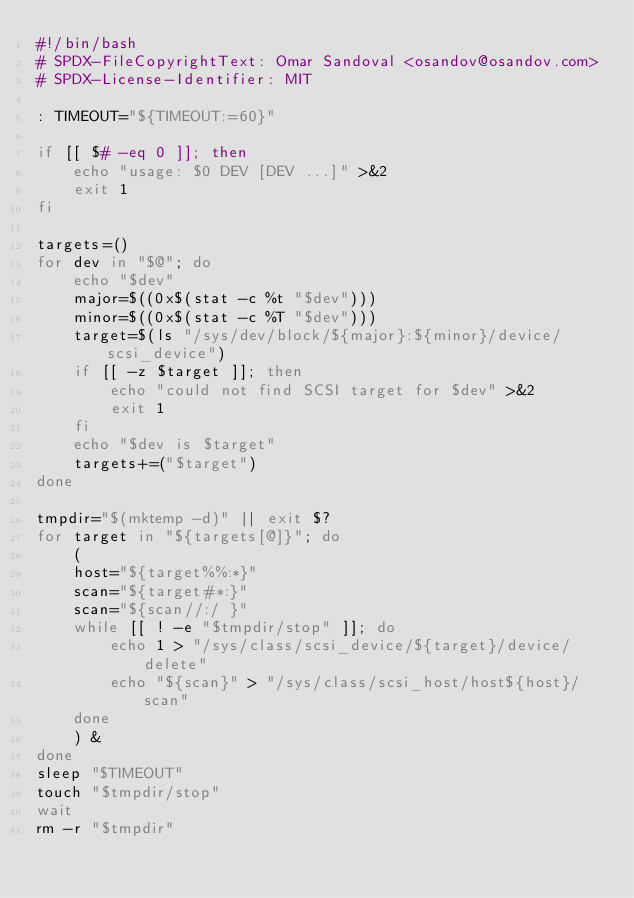Convert code to text. <code><loc_0><loc_0><loc_500><loc_500><_Bash_>#!/bin/bash
# SPDX-FileCopyrightText: Omar Sandoval <osandov@osandov.com>
# SPDX-License-Identifier: MIT

: TIMEOUT="${TIMEOUT:=60}"

if [[ $# -eq 0 ]]; then
	echo "usage: $0 DEV [DEV ...]" >&2
	exit 1
fi

targets=()
for dev in "$@"; do
	echo "$dev"
	major=$((0x$(stat -c %t "$dev")))
	minor=$((0x$(stat -c %T "$dev")))
	target=$(ls "/sys/dev/block/${major}:${minor}/device/scsi_device")
	if [[ -z $target ]]; then
		echo "could not find SCSI target for $dev" >&2
		exit 1
	fi
	echo "$dev is $target"
	targets+=("$target")
done

tmpdir="$(mktemp -d)" || exit $?
for target in "${targets[@]}"; do
	(
	host="${target%%:*}"
	scan="${target#*:}"
	scan="${scan//:/ }"
	while [[ ! -e "$tmpdir/stop" ]]; do
		echo 1 > "/sys/class/scsi_device/${target}/device/delete"
		echo "${scan}" > "/sys/class/scsi_host/host${host}/scan"
	done
	) &
done
sleep "$TIMEOUT"
touch "$tmpdir/stop"
wait
rm -r "$tmpdir"
</code> 